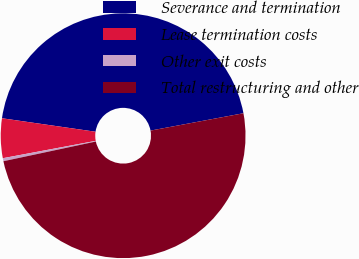Convert chart to OTSL. <chart><loc_0><loc_0><loc_500><loc_500><pie_chart><fcel>Severance and termination<fcel>Lease termination costs<fcel>Other exit costs<fcel>Total restructuring and other<nl><fcel>44.78%<fcel>5.22%<fcel>0.4%<fcel>49.6%<nl></chart> 